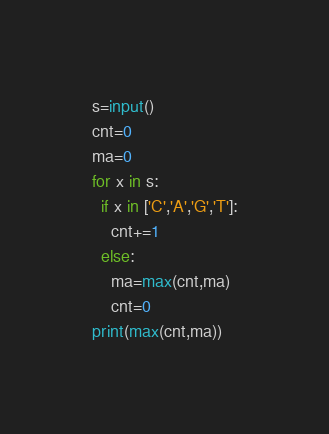<code> <loc_0><loc_0><loc_500><loc_500><_Python_>s=input()
cnt=0
ma=0
for x in s:
  if x in ['C','A','G','T']:
    cnt+=1
  else:
    ma=max(cnt,ma)
    cnt=0
print(max(cnt,ma))</code> 